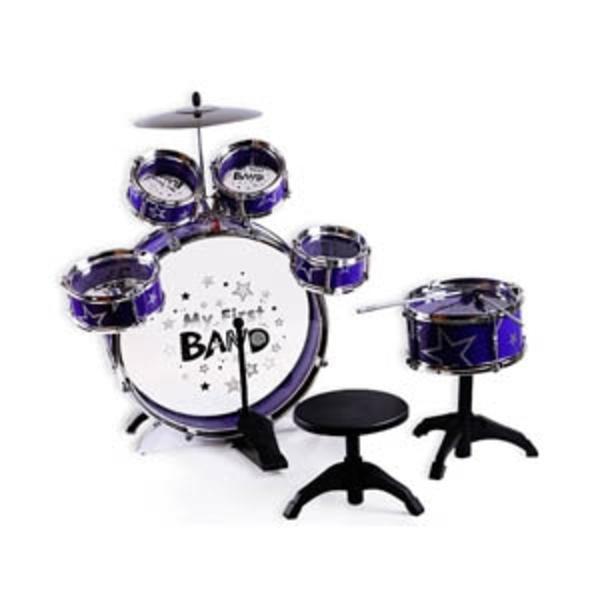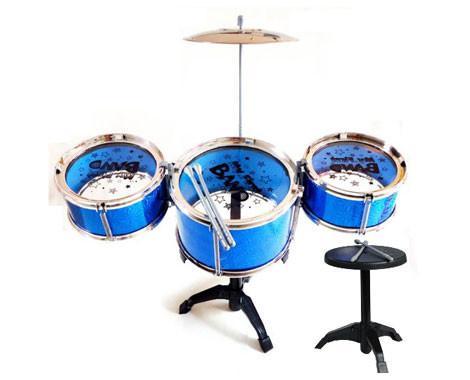The first image is the image on the left, the second image is the image on the right. Given the left and right images, does the statement "One drum set consists of three drums in a row and a high hat above them." hold true? Answer yes or no. Yes. The first image is the image on the left, the second image is the image on the right. Analyze the images presented: Is the assertion "Eight or more drums are visible." valid? Answer yes or no. Yes. 